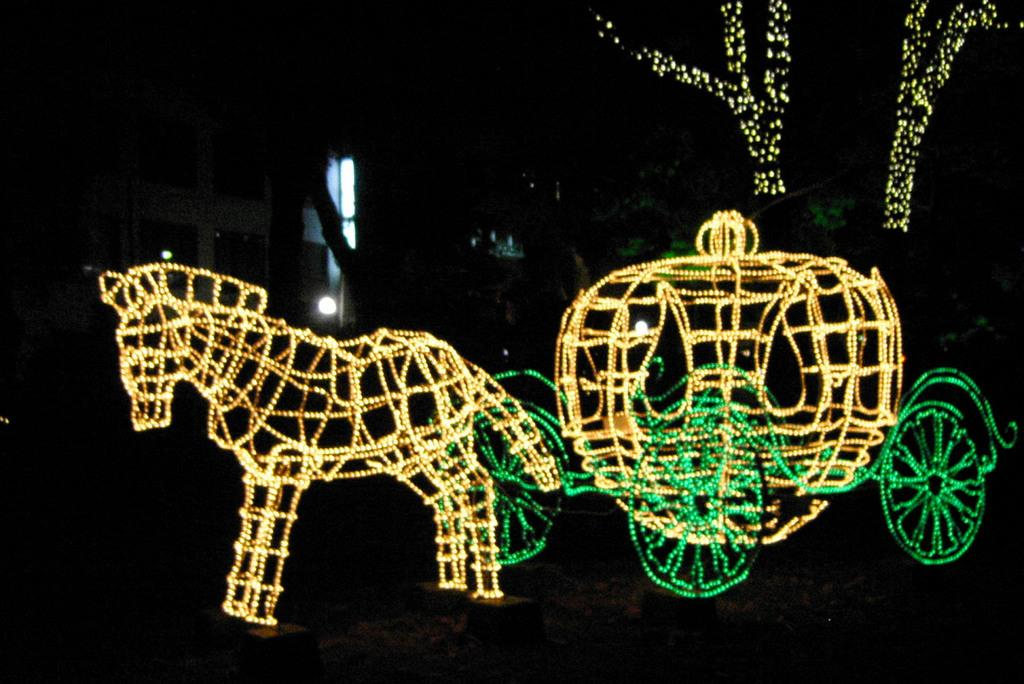What animal is present in the image? There is a horse in the image. What is attached to the horse? There is a cart in the image that is attached to the horse. What feature does the cart have? The cart has rope lights. What type of structure can be seen in the image? There is a house in the image. What type of vegetation is present in the image? There are trees in the image. What feature do the trees have? The trees have lights. How would you describe the overall lighting in the image? The background of the image is dark. What view can be seen from the father's perspective in the image? There is no father present in the image, so it is not possible to determine a view from their perspective. 